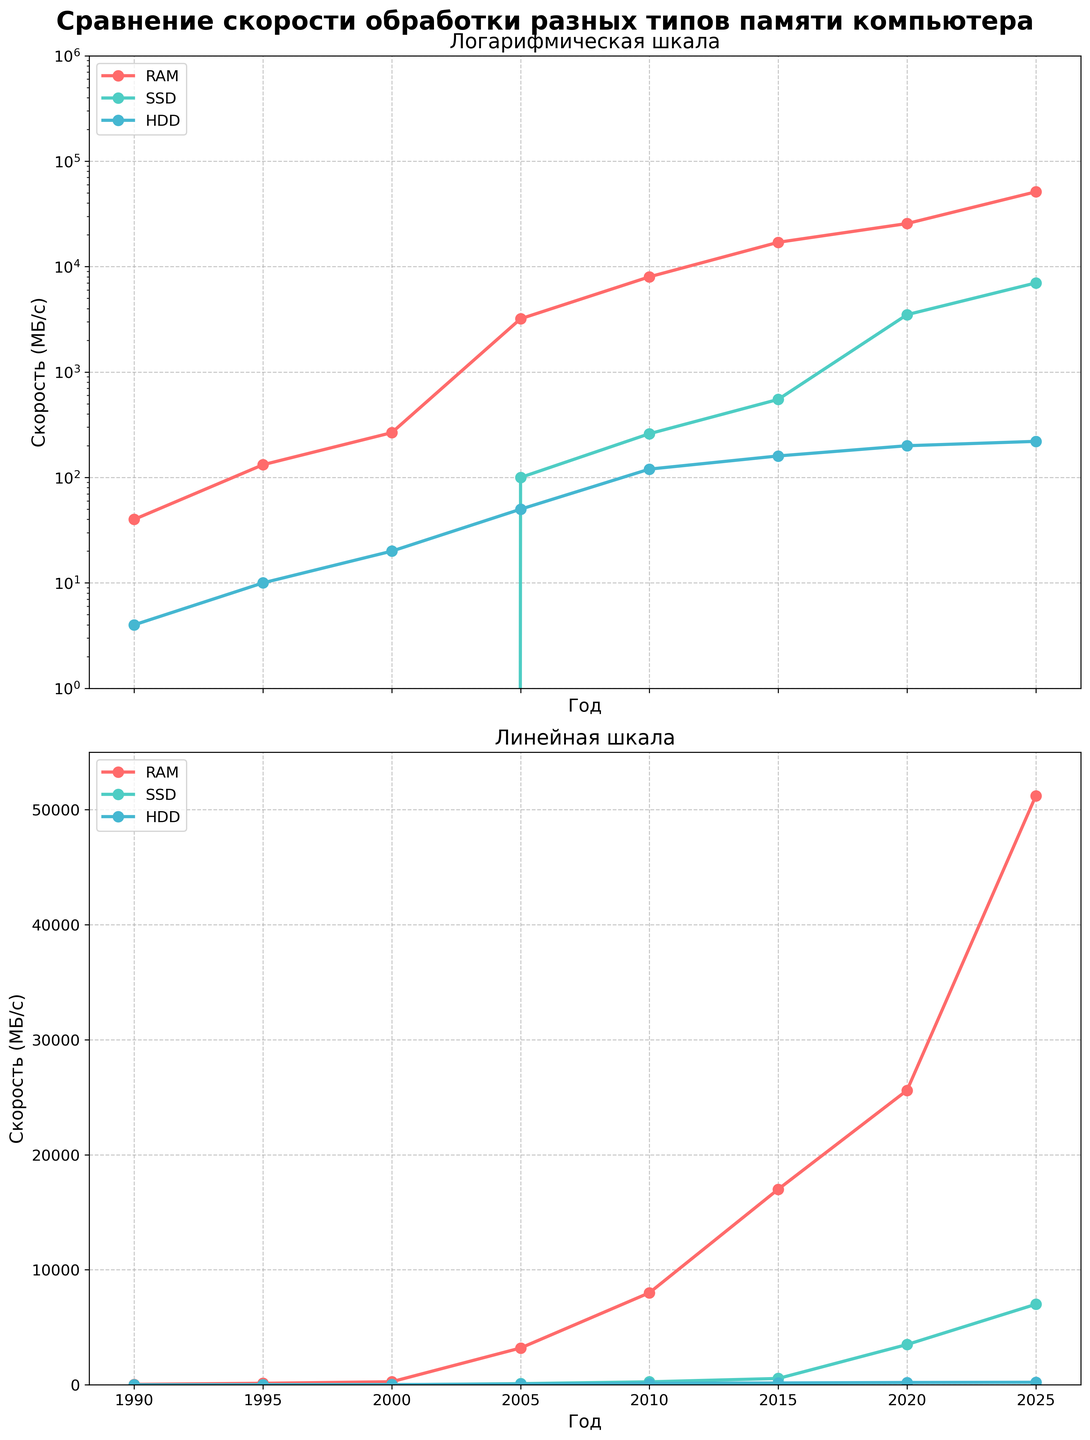What is the title of the figure? The title is displayed at the top of the figure and it reads "Сравнение скорости обработки разных типов памяти компьютера".
Answer: Сравнение скорости обработки разных типов памяти компьютера How many memory types are compared in this figure? The legend in the figure shows three labels corresponding to the lines: RAM, SSD, and HDD.
Answer: 3 What are the colors used for SSD and HDD lines? According to the lines and corresponding labels in the legend, SSD is represented by a color similar to cyan and HDD by a blue color.
Answer: Cyan and blue What is the y-axis label for both subplots? The y-axis label for both subplots is "Скорость (МБ/с)", which means "Speed (MB/s)" in English.
Answer: Скорость (МБ/с) What scale is used for the y-axis in the first subplot? The title of the first subplot reads "Логарифмическая шкала", meaning logarithmic scale in English, and the y-axis values increase by powers of ten.
Answer: Logarithmic Which memory type shows the highest processing speed by 2025? In both subplots, the RAM line is at the topmost position in 2025 with a value of 51200 MB/s, indicating it's the fastest.
Answer: RAM What is the processing speed of HDD in 2000 according to this figure? By locating the year 2000 on the x-axis and following the HDD line, the speed for HDD in 2000 is 20 MB/s.
Answer: 20 MB/s Between which years did SSD see the most significant increase in processing speed? Observing the steepest part of the SSD line, the most significant increase appears between 2015 (550 MB/s) and 2020 (3500 MB/s).
Answer: 2015 to 2020 How do RAM and HDD speeds compare in the year 2005? In 2005, the RAM speed is at 3200 MB/s and the HDD speed is at 50 MB/s. Thus, RAM is significantly faster than HDD.
Answer: RAM is much faster What is the average processing speed of RAM from 1990 to 2025? The RAM speeds are: 40, 132, 266, 3200, 8000, 17000, 25600, 51200. Summing these values gives 105438 MB/s. There are 8 data points, so the average is 105438 / 8.
Answer: 13179.75 MB/s 